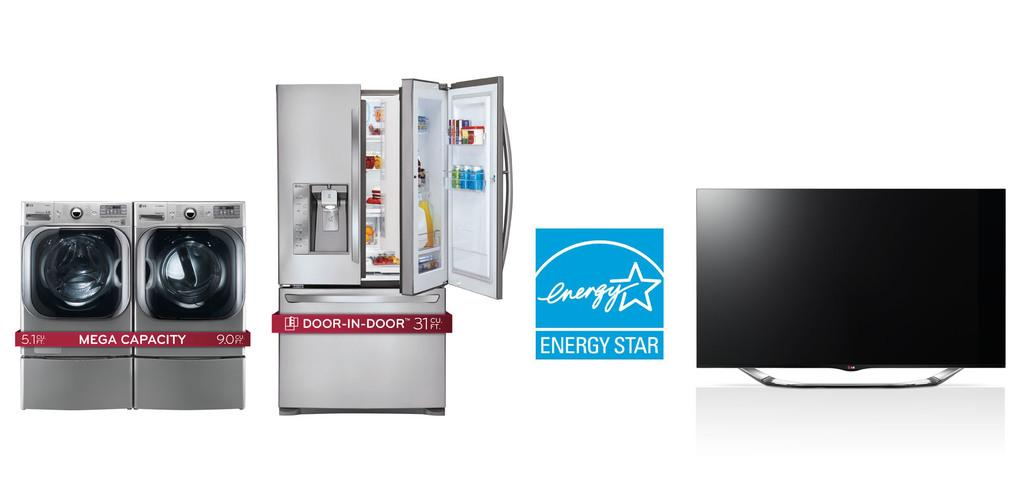What type of appliances can be seen in the image? There are washing machines, a refrigerator, and a television in the image. What color is the background of the image? The background of the image is white. Reasoning: Let's think step by identifying the main subjects and objects in the image based on the provided facts. We then formulate questions that focus on the location and characteristics of these subjects and objects, ensuring that each question can be answered definitively with the information given. We avoid yes/no questions and ensure that the language is simple and clear. Absurd Question/Answer: What type of statement can be seen on the stone in the image? There is no stone present in the image, so it is not possible to answer that question. What type of stone can be seen in the image? There is no stone present in the image, so it is not possible to answer that question. 